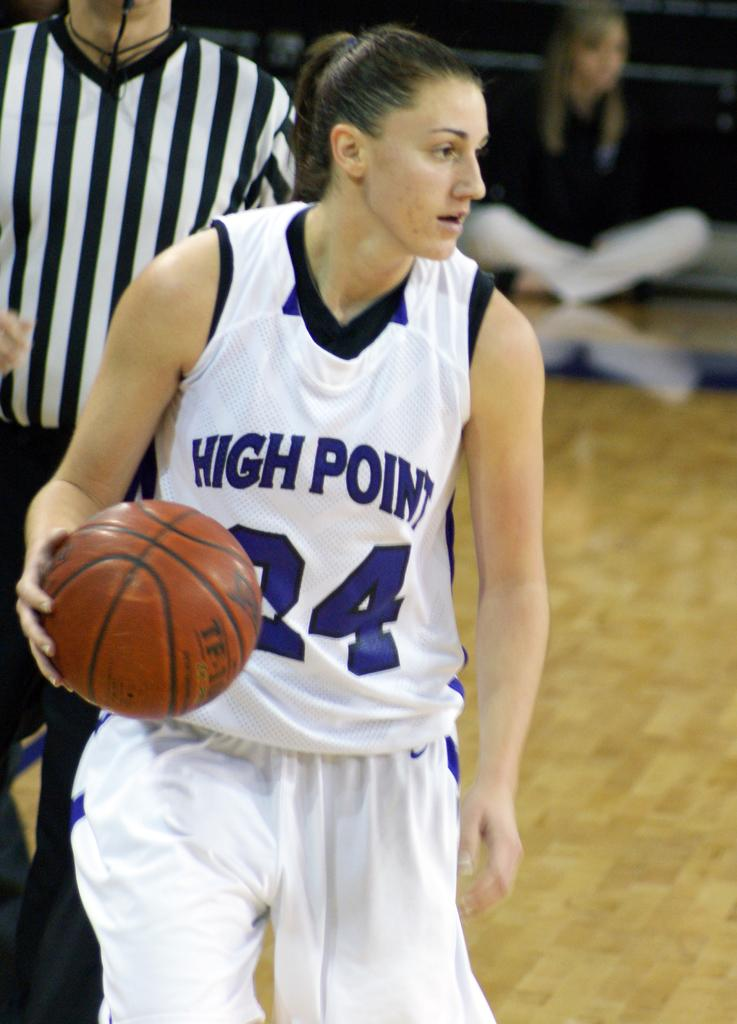<image>
Provide a brief description of the given image. Woman playing for High Point dribbling a basketball. 